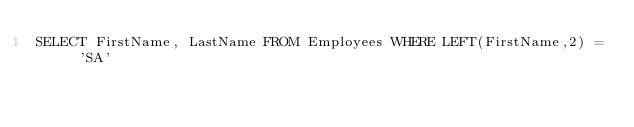<code> <loc_0><loc_0><loc_500><loc_500><_SQL_>SELECT FirstName, LastName FROM Employees WHERE LEFT(FirstName,2) = 'SA'</code> 